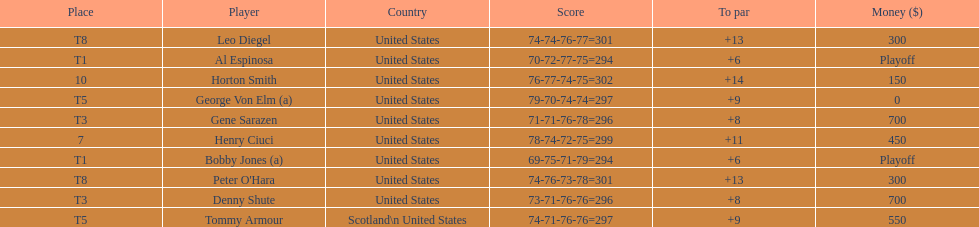Who was the last player in the top 10? Horton Smith. 